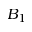Convert formula to latex. <formula><loc_0><loc_0><loc_500><loc_500>B _ { 1 }</formula> 